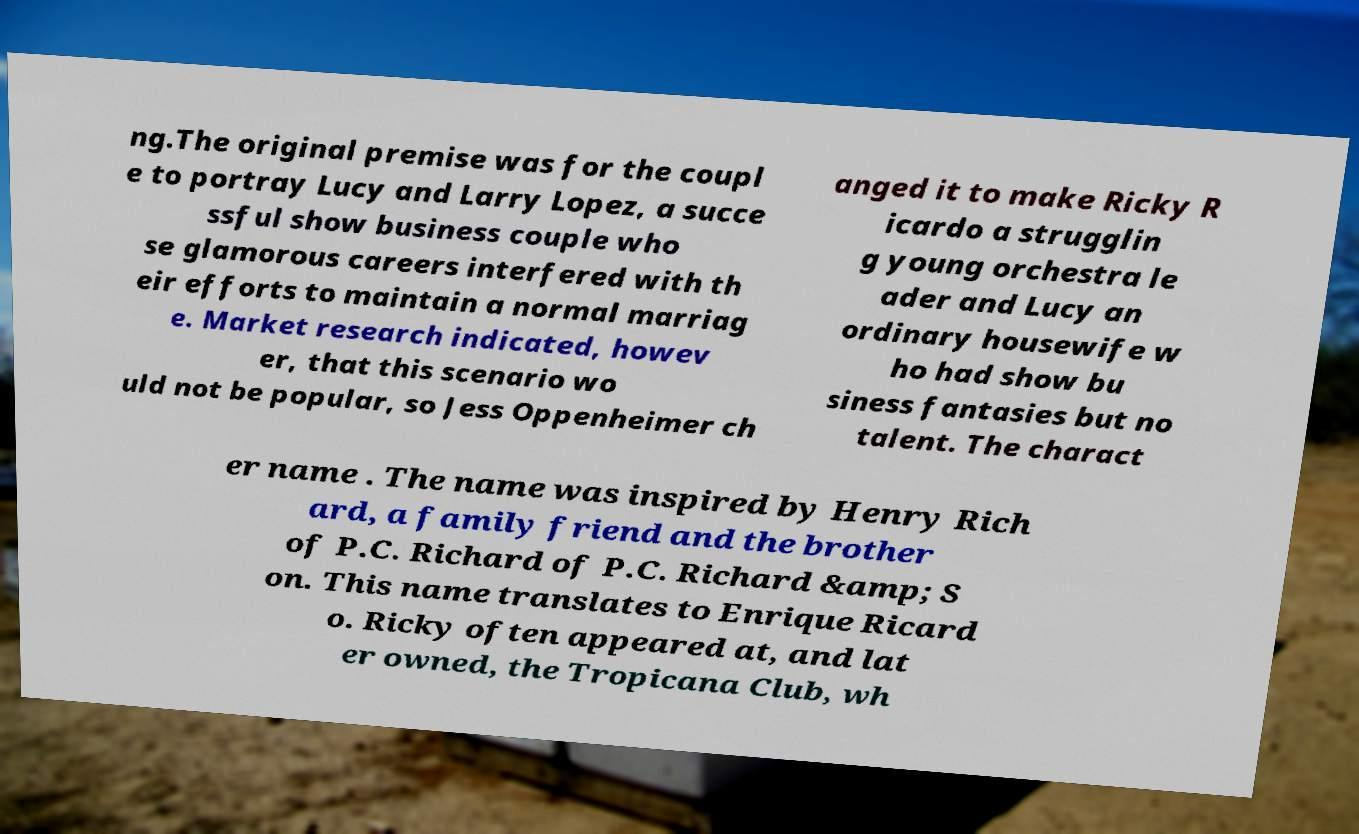Could you assist in decoding the text presented in this image and type it out clearly? ng.The original premise was for the coupl e to portray Lucy and Larry Lopez, a succe ssful show business couple who se glamorous careers interfered with th eir efforts to maintain a normal marriag e. Market research indicated, howev er, that this scenario wo uld not be popular, so Jess Oppenheimer ch anged it to make Ricky R icardo a strugglin g young orchestra le ader and Lucy an ordinary housewife w ho had show bu siness fantasies but no talent. The charact er name . The name was inspired by Henry Rich ard, a family friend and the brother of P.C. Richard of P.C. Richard &amp; S on. This name translates to Enrique Ricard o. Ricky often appeared at, and lat er owned, the Tropicana Club, wh 